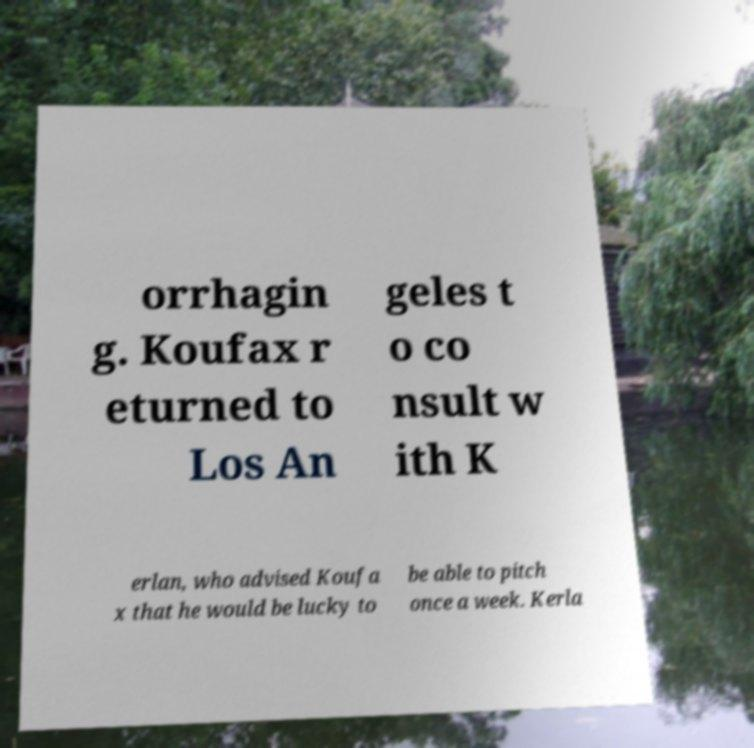Please read and relay the text visible in this image. What does it say? orrhagin g. Koufax r eturned to Los An geles t o co nsult w ith K erlan, who advised Koufa x that he would be lucky to be able to pitch once a week. Kerla 